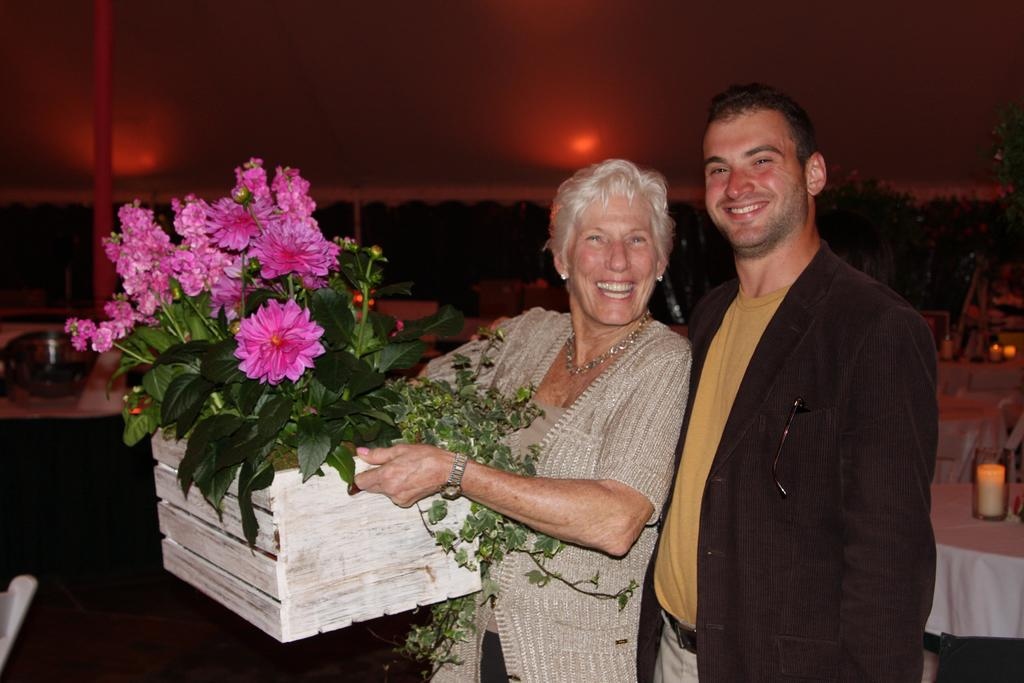How many people are present in the image? There are two people in the image, a guy and a lady. What is the lady holding in the image? The lady is holding a plant in the image. What is the primary piece of furniture in the image? There is a table in the image. What can be seen on the table? There are things placed on the table in the image. What type of system is the lady using to communicate with her friends in the image? There is no mention of friends or a communication system in the image; it only shows a lady holding a plant and a guy. 